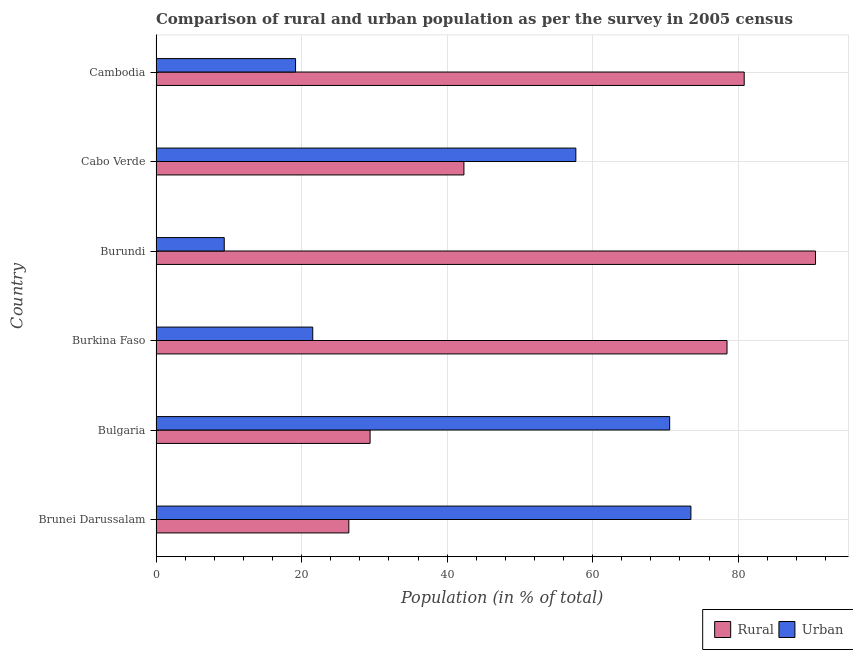How many different coloured bars are there?
Your answer should be very brief. 2. How many groups of bars are there?
Provide a short and direct response. 6. Are the number of bars on each tick of the Y-axis equal?
Provide a short and direct response. Yes. How many bars are there on the 4th tick from the bottom?
Offer a very short reply. 2. What is the label of the 5th group of bars from the top?
Offer a very short reply. Bulgaria. What is the urban population in Burundi?
Offer a very short reply. 9.38. Across all countries, what is the maximum urban population?
Provide a succinct answer. 73.5. Across all countries, what is the minimum urban population?
Give a very brief answer. 9.38. In which country was the urban population maximum?
Keep it short and to the point. Brunei Darussalam. In which country was the urban population minimum?
Your response must be concise. Burundi. What is the total rural population in the graph?
Offer a terse response. 348.14. What is the difference between the urban population in Burundi and that in Cabo Verde?
Offer a terse response. -48.31. What is the difference between the rural population in Burkina Faso and the urban population in Cambodia?
Give a very brief answer. 59.29. What is the average urban population per country?
Provide a short and direct response. 41.98. What is the difference between the rural population and urban population in Bulgaria?
Your answer should be very brief. -41.17. What is the ratio of the rural population in Brunei Darussalam to that in Burkina Faso?
Your answer should be compact. 0.34. Is the urban population in Brunei Darussalam less than that in Burkina Faso?
Provide a short and direct response. No. What is the difference between the highest and the second highest urban population?
Your answer should be compact. 2.92. What is the difference between the highest and the lowest urban population?
Provide a short and direct response. 64.13. In how many countries, is the rural population greater than the average rural population taken over all countries?
Your response must be concise. 3. What does the 1st bar from the top in Cambodia represents?
Offer a very short reply. Urban. What does the 1st bar from the bottom in Burundi represents?
Provide a succinct answer. Rural. How many bars are there?
Your answer should be very brief. 12. Are all the bars in the graph horizontal?
Keep it short and to the point. Yes. How many countries are there in the graph?
Your response must be concise. 6. What is the difference between two consecutive major ticks on the X-axis?
Give a very brief answer. 20. Are the values on the major ticks of X-axis written in scientific E-notation?
Provide a succinct answer. No. How many legend labels are there?
Your answer should be very brief. 2. How are the legend labels stacked?
Offer a very short reply. Horizontal. What is the title of the graph?
Your answer should be very brief. Comparison of rural and urban population as per the survey in 2005 census. What is the label or title of the X-axis?
Offer a very short reply. Population (in % of total). What is the Population (in % of total) in Rural in Brunei Darussalam?
Provide a succinct answer. 26.5. What is the Population (in % of total) in Urban in Brunei Darussalam?
Give a very brief answer. 73.5. What is the Population (in % of total) of Rural in Bulgaria?
Your response must be concise. 29.42. What is the Population (in % of total) in Urban in Bulgaria?
Your response must be concise. 70.58. What is the Population (in % of total) of Rural in Burkina Faso?
Give a very brief answer. 78.46. What is the Population (in % of total) in Urban in Burkina Faso?
Your answer should be very brief. 21.54. What is the Population (in % of total) in Rural in Burundi?
Ensure brevity in your answer.  90.62. What is the Population (in % of total) in Urban in Burundi?
Your response must be concise. 9.38. What is the Population (in % of total) in Rural in Cabo Verde?
Your answer should be compact. 42.31. What is the Population (in % of total) in Urban in Cabo Verde?
Your answer should be very brief. 57.69. What is the Population (in % of total) of Rural in Cambodia?
Make the answer very short. 80.83. What is the Population (in % of total) of Urban in Cambodia?
Your answer should be compact. 19.17. Across all countries, what is the maximum Population (in % of total) of Rural?
Offer a terse response. 90.62. Across all countries, what is the maximum Population (in % of total) of Urban?
Provide a short and direct response. 73.5. Across all countries, what is the minimum Population (in % of total) in Rural?
Offer a terse response. 26.5. Across all countries, what is the minimum Population (in % of total) in Urban?
Provide a short and direct response. 9.38. What is the total Population (in % of total) in Rural in the graph?
Offer a very short reply. 348.14. What is the total Population (in % of total) of Urban in the graph?
Keep it short and to the point. 251.86. What is the difference between the Population (in % of total) of Rural in Brunei Darussalam and that in Bulgaria?
Provide a short and direct response. -2.92. What is the difference between the Population (in % of total) in Urban in Brunei Darussalam and that in Bulgaria?
Your answer should be very brief. 2.92. What is the difference between the Population (in % of total) of Rural in Brunei Darussalam and that in Burkina Faso?
Make the answer very short. -51.97. What is the difference between the Population (in % of total) in Urban in Brunei Darussalam and that in Burkina Faso?
Offer a very short reply. 51.97. What is the difference between the Population (in % of total) in Rural in Brunei Darussalam and that in Burundi?
Your response must be concise. -64.13. What is the difference between the Population (in % of total) of Urban in Brunei Darussalam and that in Burundi?
Your answer should be very brief. 64.13. What is the difference between the Population (in % of total) in Rural in Brunei Darussalam and that in Cabo Verde?
Offer a terse response. -15.81. What is the difference between the Population (in % of total) of Urban in Brunei Darussalam and that in Cabo Verde?
Offer a terse response. 15.81. What is the difference between the Population (in % of total) in Rural in Brunei Darussalam and that in Cambodia?
Provide a short and direct response. -54.33. What is the difference between the Population (in % of total) in Urban in Brunei Darussalam and that in Cambodia?
Ensure brevity in your answer.  54.33. What is the difference between the Population (in % of total) of Rural in Bulgaria and that in Burkina Faso?
Offer a very short reply. -49.05. What is the difference between the Population (in % of total) in Urban in Bulgaria and that in Burkina Faso?
Ensure brevity in your answer.  49.05. What is the difference between the Population (in % of total) in Rural in Bulgaria and that in Burundi?
Your answer should be compact. -61.21. What is the difference between the Population (in % of total) in Urban in Bulgaria and that in Burundi?
Make the answer very short. 61.21. What is the difference between the Population (in % of total) of Rural in Bulgaria and that in Cabo Verde?
Ensure brevity in your answer.  -12.89. What is the difference between the Population (in % of total) of Urban in Bulgaria and that in Cabo Verde?
Keep it short and to the point. 12.89. What is the difference between the Population (in % of total) of Rural in Bulgaria and that in Cambodia?
Your response must be concise. -51.41. What is the difference between the Population (in % of total) in Urban in Bulgaria and that in Cambodia?
Give a very brief answer. 51.41. What is the difference between the Population (in % of total) in Rural in Burkina Faso and that in Burundi?
Your answer should be compact. -12.16. What is the difference between the Population (in % of total) of Urban in Burkina Faso and that in Burundi?
Provide a succinct answer. 12.16. What is the difference between the Population (in % of total) in Rural in Burkina Faso and that in Cabo Verde?
Offer a terse response. 36.15. What is the difference between the Population (in % of total) in Urban in Burkina Faso and that in Cabo Verde?
Your answer should be compact. -36.15. What is the difference between the Population (in % of total) in Rural in Burkina Faso and that in Cambodia?
Your answer should be compact. -2.36. What is the difference between the Population (in % of total) in Urban in Burkina Faso and that in Cambodia?
Your answer should be very brief. 2.36. What is the difference between the Population (in % of total) of Rural in Burundi and that in Cabo Verde?
Ensure brevity in your answer.  48.31. What is the difference between the Population (in % of total) of Urban in Burundi and that in Cabo Verde?
Ensure brevity in your answer.  -48.31. What is the difference between the Population (in % of total) in Rural in Burundi and that in Cambodia?
Your answer should be very brief. 9.8. What is the difference between the Population (in % of total) of Urban in Burundi and that in Cambodia?
Your answer should be very brief. -9.8. What is the difference between the Population (in % of total) in Rural in Cabo Verde and that in Cambodia?
Make the answer very short. -38.52. What is the difference between the Population (in % of total) in Urban in Cabo Verde and that in Cambodia?
Ensure brevity in your answer.  38.52. What is the difference between the Population (in % of total) of Rural in Brunei Darussalam and the Population (in % of total) of Urban in Bulgaria?
Provide a succinct answer. -44.09. What is the difference between the Population (in % of total) of Rural in Brunei Darussalam and the Population (in % of total) of Urban in Burkina Faso?
Your answer should be very brief. 4.96. What is the difference between the Population (in % of total) of Rural in Brunei Darussalam and the Population (in % of total) of Urban in Burundi?
Provide a succinct answer. 17.12. What is the difference between the Population (in % of total) in Rural in Brunei Darussalam and the Population (in % of total) in Urban in Cabo Verde?
Keep it short and to the point. -31.19. What is the difference between the Population (in % of total) in Rural in Brunei Darussalam and the Population (in % of total) in Urban in Cambodia?
Your answer should be compact. 7.32. What is the difference between the Population (in % of total) in Rural in Bulgaria and the Population (in % of total) in Urban in Burkina Faso?
Your answer should be compact. 7.88. What is the difference between the Population (in % of total) in Rural in Bulgaria and the Population (in % of total) in Urban in Burundi?
Ensure brevity in your answer.  20.04. What is the difference between the Population (in % of total) of Rural in Bulgaria and the Population (in % of total) of Urban in Cabo Verde?
Make the answer very short. -28.27. What is the difference between the Population (in % of total) in Rural in Bulgaria and the Population (in % of total) in Urban in Cambodia?
Offer a very short reply. 10.24. What is the difference between the Population (in % of total) in Rural in Burkina Faso and the Population (in % of total) in Urban in Burundi?
Offer a terse response. 69.09. What is the difference between the Population (in % of total) in Rural in Burkina Faso and the Population (in % of total) in Urban in Cabo Verde?
Provide a short and direct response. 20.77. What is the difference between the Population (in % of total) in Rural in Burkina Faso and the Population (in % of total) in Urban in Cambodia?
Your answer should be very brief. 59.29. What is the difference between the Population (in % of total) of Rural in Burundi and the Population (in % of total) of Urban in Cabo Verde?
Offer a terse response. 32.94. What is the difference between the Population (in % of total) in Rural in Burundi and the Population (in % of total) in Urban in Cambodia?
Your answer should be very brief. 71.45. What is the difference between the Population (in % of total) of Rural in Cabo Verde and the Population (in % of total) of Urban in Cambodia?
Offer a terse response. 23.14. What is the average Population (in % of total) in Rural per country?
Your answer should be very brief. 58.02. What is the average Population (in % of total) in Urban per country?
Your answer should be compact. 41.98. What is the difference between the Population (in % of total) of Rural and Population (in % of total) of Urban in Brunei Darussalam?
Offer a very short reply. -47.01. What is the difference between the Population (in % of total) of Rural and Population (in % of total) of Urban in Bulgaria?
Provide a short and direct response. -41.17. What is the difference between the Population (in % of total) of Rural and Population (in % of total) of Urban in Burkina Faso?
Offer a very short reply. 56.93. What is the difference between the Population (in % of total) of Rural and Population (in % of total) of Urban in Burundi?
Your answer should be compact. 81.25. What is the difference between the Population (in % of total) in Rural and Population (in % of total) in Urban in Cabo Verde?
Offer a very short reply. -15.38. What is the difference between the Population (in % of total) in Rural and Population (in % of total) in Urban in Cambodia?
Keep it short and to the point. 61.65. What is the ratio of the Population (in % of total) of Rural in Brunei Darussalam to that in Bulgaria?
Offer a terse response. 0.9. What is the ratio of the Population (in % of total) in Urban in Brunei Darussalam to that in Bulgaria?
Keep it short and to the point. 1.04. What is the ratio of the Population (in % of total) of Rural in Brunei Darussalam to that in Burkina Faso?
Your answer should be compact. 0.34. What is the ratio of the Population (in % of total) of Urban in Brunei Darussalam to that in Burkina Faso?
Provide a succinct answer. 3.41. What is the ratio of the Population (in % of total) of Rural in Brunei Darussalam to that in Burundi?
Offer a very short reply. 0.29. What is the ratio of the Population (in % of total) in Urban in Brunei Darussalam to that in Burundi?
Keep it short and to the point. 7.84. What is the ratio of the Population (in % of total) of Rural in Brunei Darussalam to that in Cabo Verde?
Give a very brief answer. 0.63. What is the ratio of the Population (in % of total) of Urban in Brunei Darussalam to that in Cabo Verde?
Offer a terse response. 1.27. What is the ratio of the Population (in % of total) of Rural in Brunei Darussalam to that in Cambodia?
Offer a very short reply. 0.33. What is the ratio of the Population (in % of total) of Urban in Brunei Darussalam to that in Cambodia?
Keep it short and to the point. 3.83. What is the ratio of the Population (in % of total) in Rural in Bulgaria to that in Burkina Faso?
Your answer should be compact. 0.37. What is the ratio of the Population (in % of total) of Urban in Bulgaria to that in Burkina Faso?
Offer a terse response. 3.28. What is the ratio of the Population (in % of total) of Rural in Bulgaria to that in Burundi?
Keep it short and to the point. 0.32. What is the ratio of the Population (in % of total) in Urban in Bulgaria to that in Burundi?
Give a very brief answer. 7.53. What is the ratio of the Population (in % of total) of Rural in Bulgaria to that in Cabo Verde?
Your response must be concise. 0.7. What is the ratio of the Population (in % of total) of Urban in Bulgaria to that in Cabo Verde?
Give a very brief answer. 1.22. What is the ratio of the Population (in % of total) in Rural in Bulgaria to that in Cambodia?
Your answer should be very brief. 0.36. What is the ratio of the Population (in % of total) of Urban in Bulgaria to that in Cambodia?
Keep it short and to the point. 3.68. What is the ratio of the Population (in % of total) of Rural in Burkina Faso to that in Burundi?
Keep it short and to the point. 0.87. What is the ratio of the Population (in % of total) of Urban in Burkina Faso to that in Burundi?
Your response must be concise. 2.3. What is the ratio of the Population (in % of total) in Rural in Burkina Faso to that in Cabo Verde?
Ensure brevity in your answer.  1.85. What is the ratio of the Population (in % of total) in Urban in Burkina Faso to that in Cabo Verde?
Your response must be concise. 0.37. What is the ratio of the Population (in % of total) of Rural in Burkina Faso to that in Cambodia?
Your answer should be very brief. 0.97. What is the ratio of the Population (in % of total) of Urban in Burkina Faso to that in Cambodia?
Provide a succinct answer. 1.12. What is the ratio of the Population (in % of total) in Rural in Burundi to that in Cabo Verde?
Provide a short and direct response. 2.14. What is the ratio of the Population (in % of total) in Urban in Burundi to that in Cabo Verde?
Your answer should be very brief. 0.16. What is the ratio of the Population (in % of total) of Rural in Burundi to that in Cambodia?
Offer a very short reply. 1.12. What is the ratio of the Population (in % of total) in Urban in Burundi to that in Cambodia?
Offer a very short reply. 0.49. What is the ratio of the Population (in % of total) in Rural in Cabo Verde to that in Cambodia?
Your response must be concise. 0.52. What is the ratio of the Population (in % of total) in Urban in Cabo Verde to that in Cambodia?
Keep it short and to the point. 3.01. What is the difference between the highest and the second highest Population (in % of total) in Rural?
Keep it short and to the point. 9.8. What is the difference between the highest and the second highest Population (in % of total) of Urban?
Give a very brief answer. 2.92. What is the difference between the highest and the lowest Population (in % of total) in Rural?
Your answer should be very brief. 64.13. What is the difference between the highest and the lowest Population (in % of total) in Urban?
Your answer should be very brief. 64.13. 